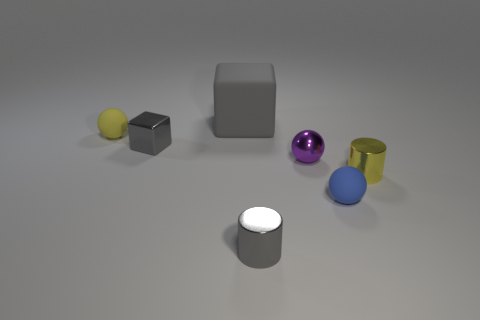There is a rubber thing that is the same color as the tiny metal block; what shape is it?
Provide a succinct answer. Cube. There is a shiny cylinder that is in front of the tiny yellow cylinder; is its size the same as the gray thing that is on the left side of the large gray cube?
Provide a short and direct response. Yes. What number of objects are either large gray things or small things that are right of the tiny gray cylinder?
Your answer should be compact. 4. The big rubber cube has what color?
Provide a succinct answer. Gray. There is a gray block that is behind the tiny yellow thing that is left of the tiny cylinder that is left of the small blue ball; what is its material?
Offer a terse response. Rubber. What is the size of the block that is the same material as the yellow cylinder?
Keep it short and to the point. Small. Are there any cylinders of the same color as the big cube?
Your answer should be very brief. Yes. Do the matte cube and the metal cylinder in front of the blue ball have the same size?
Ensure brevity in your answer.  No. How many gray metal blocks are right of the sphere on the left side of the shiny thing to the left of the large gray rubber block?
Give a very brief answer. 1. What is the size of the rubber block that is the same color as the tiny metal cube?
Make the answer very short. Large. 